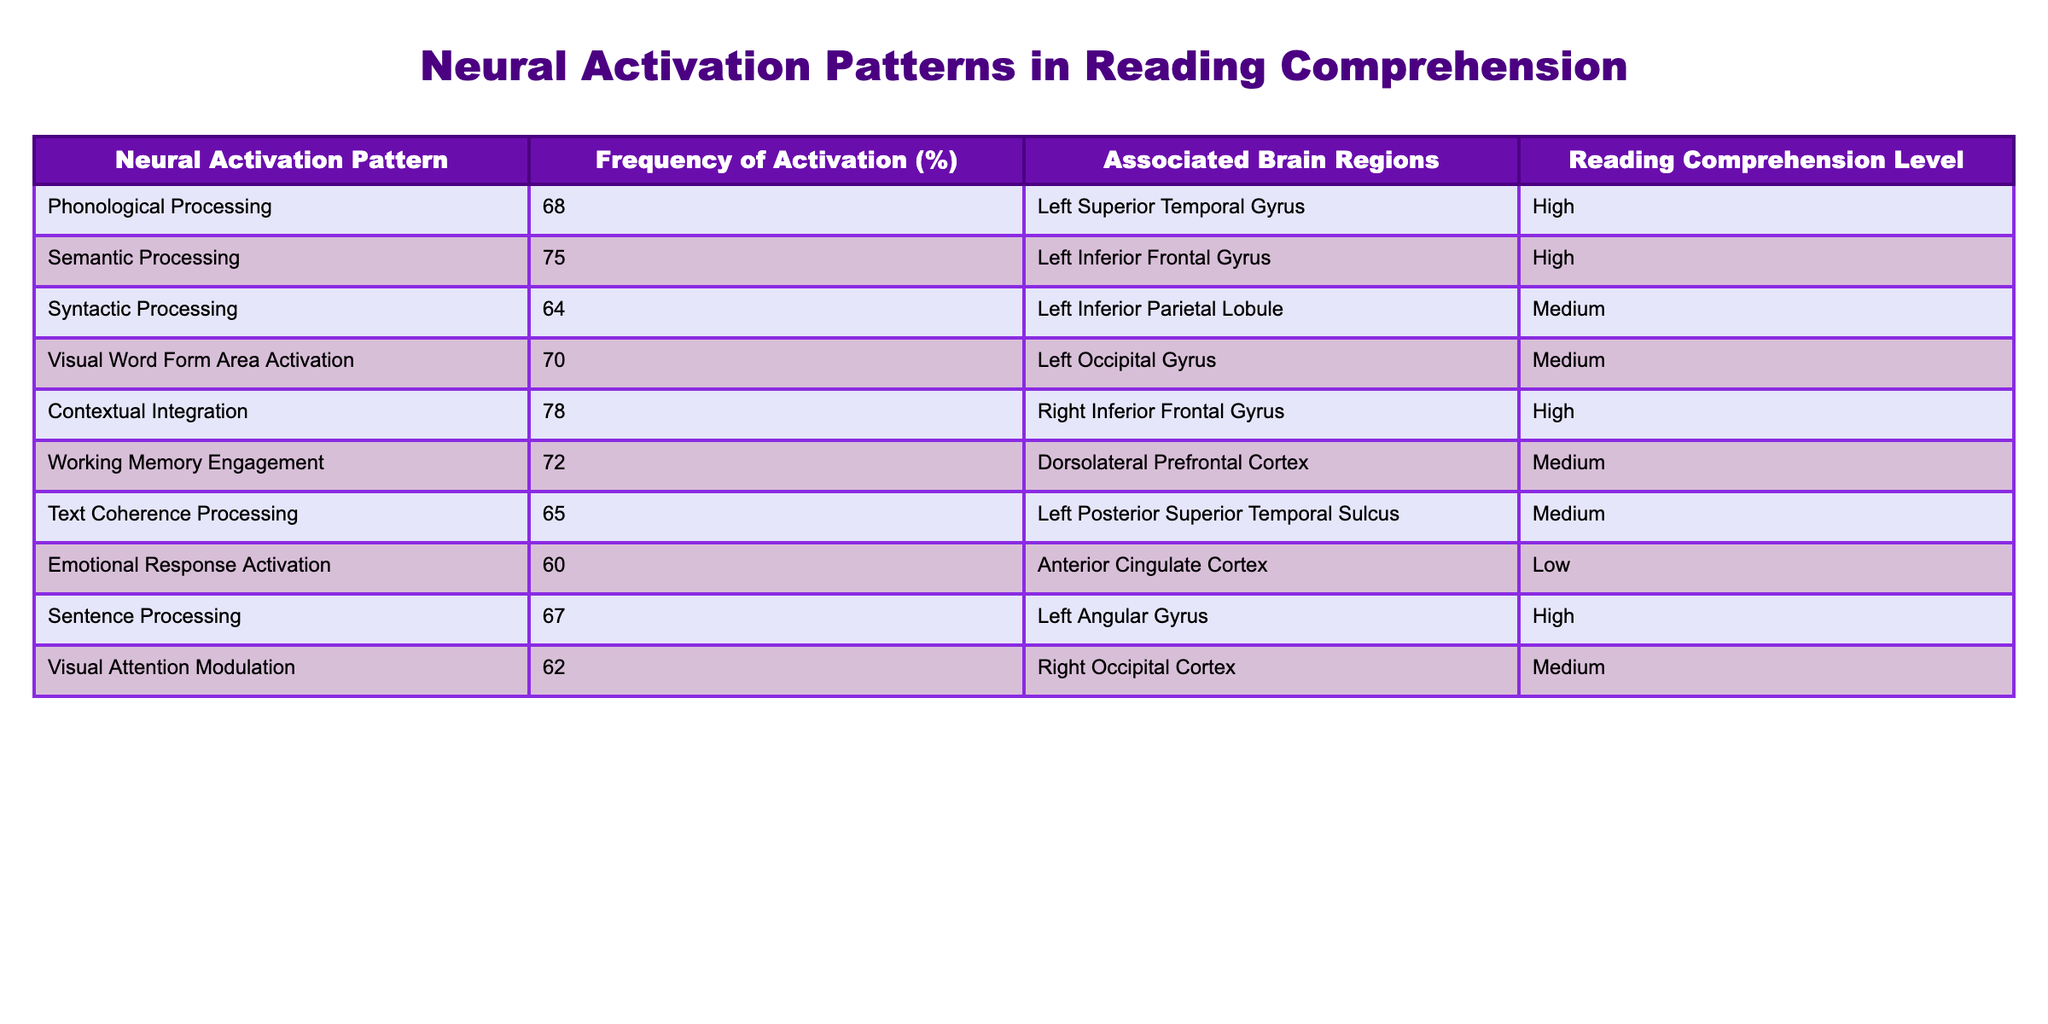What is the highest frequency of activation among the listed neural activation patterns? The highest frequency of activation in the table is 78%, which corresponds to the Contextual Integration pattern.
Answer: 78% Which brain region is associated with the Semantic Processing pattern? According to the table, the Semantic Processing pattern is associated with the Left Inferior Frontal Gyrus.
Answer: Left Inferior Frontal Gyrus What percentage of activation is associated with Text Coherence Processing? The activation frequency for Text Coherence Processing is listed as 65% in the table.
Answer: 65% Is there a neural activation pattern that has a low reading comprehension level? Yes, the Emotional Response Activation pattern has a low reading comprehension level, indicated by its classification in the table.
Answer: Yes What is the average frequency of activation for the neural activation patterns associated with high reading comprehension levels? To find the average, we take the activation frequencies of the patterns with high reading comprehension: 68%, 75%, 78%, and 67%. The sum is (68 + 75 + 78 + 67) = 288, and there are 4 such patterns. The average is 288/4 = 72%.
Answer: 72% Which neural activation pattern has the lowest frequency of activation, and what is its value? The lowest frequency of activation corresponds to the Emotional Response Activation, which is 60%.
Answer: 60% How many neural activation patterns are associated with a medium level of reading comprehension? Referring to the table, there are four patterns classified with a medium level of reading comprehension: Syntactic Processing, Visual Word Form Area Activation, Working Memory Engagement, and Visual Attention Modulation.
Answer: 4 Is there any neural activation pattern associated with both medium frequency of activation and medium reading comprehension? Yes, the Syntactic Processing, Visual Word Form Area Activation, Working Memory Engagement, and Visual Attention Modulation patterns are associated with medium frequency of activation and medium reading comprehension.
Answer: Yes What is the difference in frequency of activation between Contextual Integration and Phonological Processing? The frequency for Contextual Integration is 78% and for Phonological Processing it is 68%. The difference is 78 - 68 = 10%.
Answer: 10% 